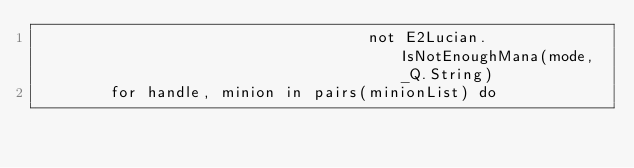Convert code to text. <code><loc_0><loc_0><loc_500><loc_500><_Lua_>                                    not E2Lucian.IsNotEnoughMana(mode, _Q.String)
        for handle, minion in pairs(minionList) do</code> 